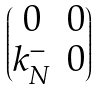Convert formula to latex. <formula><loc_0><loc_0><loc_500><loc_500>\begin{pmatrix} 0 & 0 \\ k ^ { - } _ { N } & 0 \end{pmatrix}</formula> 